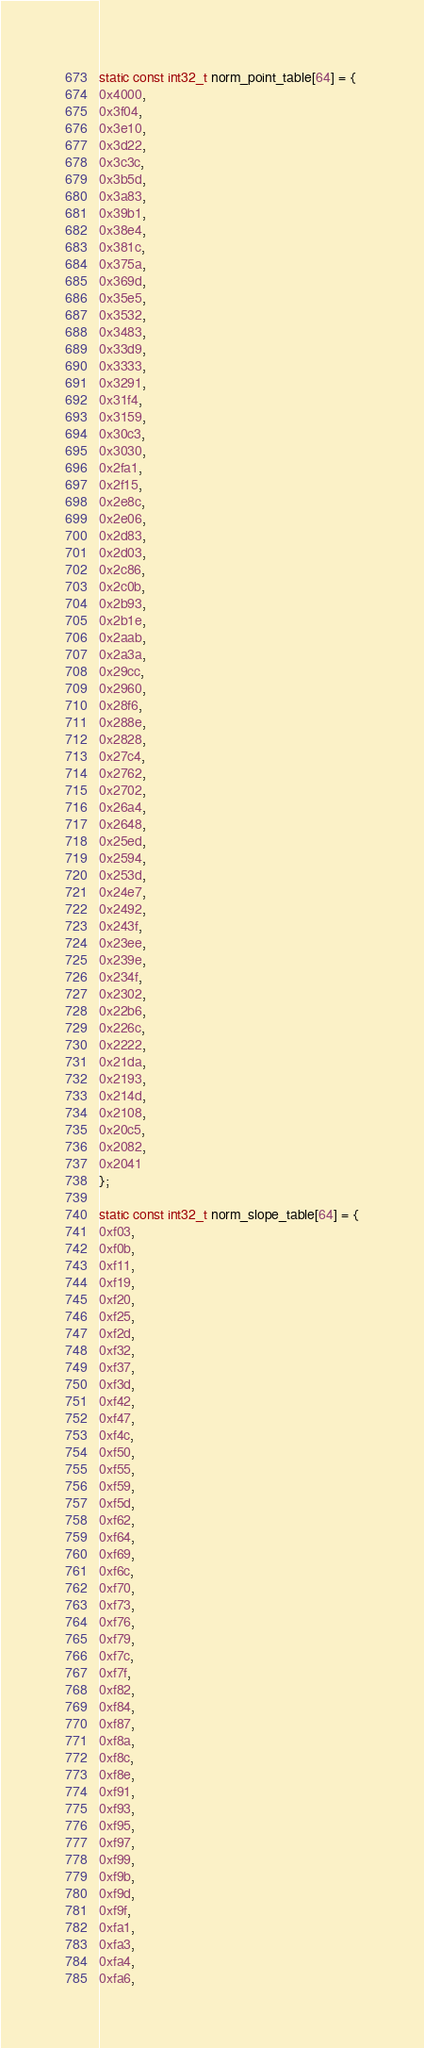Convert code to text. <code><loc_0><loc_0><loc_500><loc_500><_C_>static const int32_t norm_point_table[64] = {
0x4000,
0x3f04,
0x3e10,
0x3d22,
0x3c3c,
0x3b5d,
0x3a83,
0x39b1,
0x38e4,
0x381c,
0x375a,
0x369d,
0x35e5,
0x3532,
0x3483,
0x33d9,
0x3333,
0x3291,
0x31f4,
0x3159,
0x30c3,
0x3030,
0x2fa1,
0x2f15,
0x2e8c,
0x2e06,
0x2d83,
0x2d03,
0x2c86,
0x2c0b,
0x2b93,
0x2b1e,
0x2aab,
0x2a3a,
0x29cc,
0x2960,
0x28f6,
0x288e,
0x2828,
0x27c4,
0x2762,
0x2702,
0x26a4,
0x2648,
0x25ed,
0x2594,
0x253d,
0x24e7,
0x2492,
0x243f,
0x23ee,
0x239e,
0x234f,
0x2302,
0x22b6,
0x226c,
0x2222,
0x21da,
0x2193,
0x214d,
0x2108,
0x20c5,
0x2082,
0x2041 
};

static const int32_t norm_slope_table[64] = {
0xf03,
0xf0b,
0xf11,
0xf19,
0xf20,
0xf25,
0xf2d,
0xf32,
0xf37,
0xf3d,
0xf42,
0xf47,
0xf4c,
0xf50,
0xf55,
0xf59,
0xf5d,
0xf62,
0xf64,
0xf69,
0xf6c,
0xf70,
0xf73,
0xf76,
0xf79,
0xf7c,
0xf7f,
0xf82,
0xf84,
0xf87,
0xf8a,
0xf8c,
0xf8e,
0xf91,
0xf93,
0xf95,
0xf97,
0xf99,
0xf9b,
0xf9d,
0xf9f,
0xfa1,
0xfa3,
0xfa4,
0xfa6,</code> 